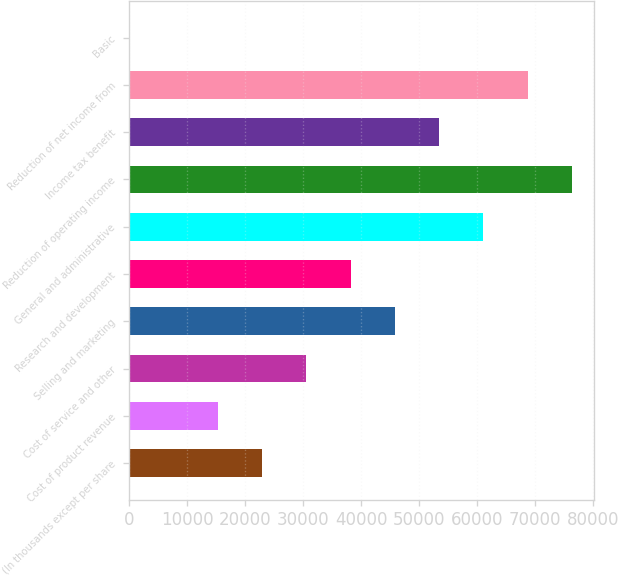Convert chart to OTSL. <chart><loc_0><loc_0><loc_500><loc_500><bar_chart><fcel>(In thousands except per share<fcel>Cost of product revenue<fcel>Cost of service and other<fcel>Selling and marketing<fcel>Research and development<fcel>General and administrative<fcel>Reduction of operating income<fcel>Income tax benefit<fcel>Reduction of net income from<fcel>Basic<nl><fcel>22894<fcel>15262.7<fcel>30525.3<fcel>45787.9<fcel>38156.6<fcel>61050.4<fcel>76313<fcel>53419.2<fcel>68681.7<fcel>0.15<nl></chart> 